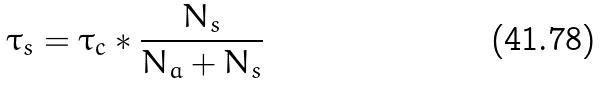Convert formula to latex. <formula><loc_0><loc_0><loc_500><loc_500>\tau _ { s } = \tau _ { c } * \frac { N _ { s } } { N _ { a } + N _ { s } }</formula> 